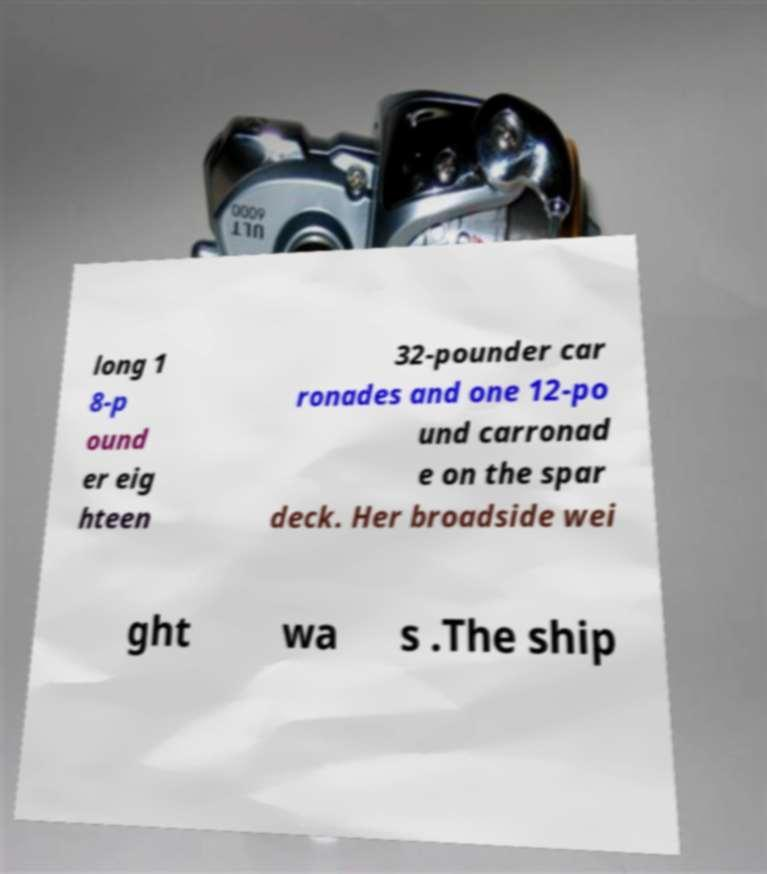Please identify and transcribe the text found in this image. long 1 8-p ound er eig hteen 32-pounder car ronades and one 12-po und carronad e on the spar deck. Her broadside wei ght wa s .The ship 